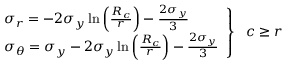Convert formula to latex. <formula><loc_0><loc_0><loc_500><loc_500>\begin{array} { l l } { \sigma _ { r } = - 2 \sigma _ { y } \ln \left ( \frac { R _ { c } } { r } \right ) - \frac { 2 \sigma _ { y } } { 3 } } \\ { \sigma _ { \theta } = \sigma _ { y } - 2 \sigma _ { y } \ln \left ( \frac { R _ { c } } { r } \right ) - \frac { 2 \sigma _ { y } } { 3 } } \end{array} \right \} \, c \geq r</formula> 